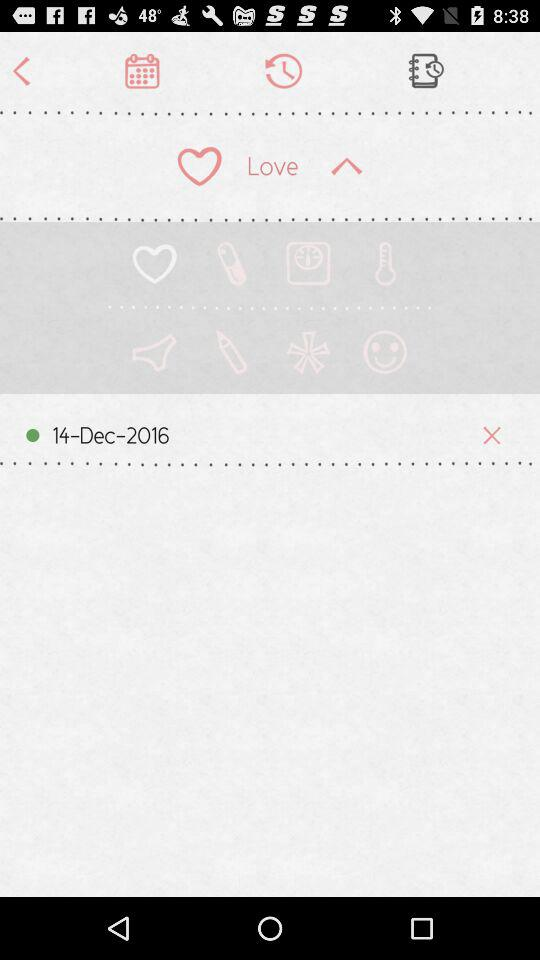What Gmail address is used? The used Gmail address is appcrawler6@gmail.com. 